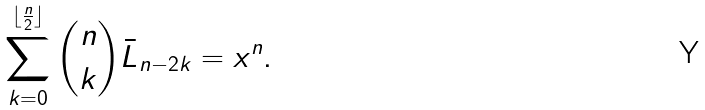Convert formula to latex. <formula><loc_0><loc_0><loc_500><loc_500>\sum _ { k = 0 } ^ { \lfloor \frac { n } { 2 } \rfloor } { n \choose k } \bar { L } _ { n - 2 k } = x ^ { n } .</formula> 